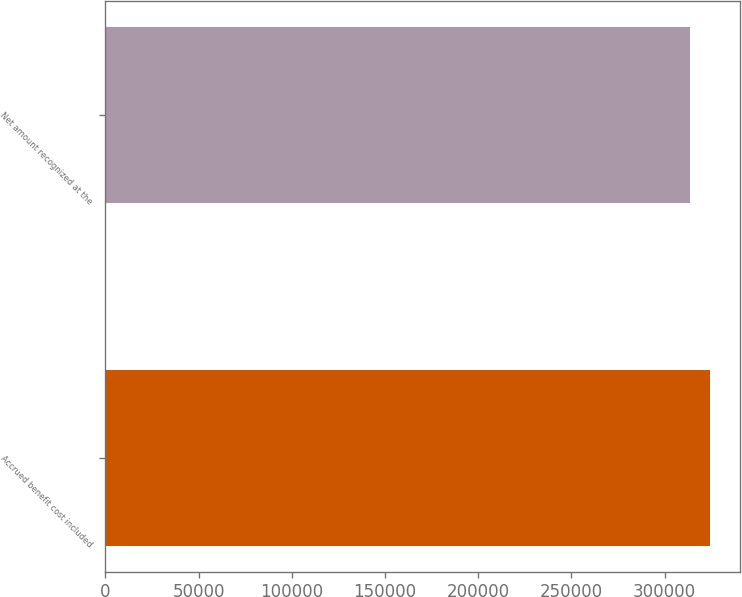Convert chart. <chart><loc_0><loc_0><loc_500><loc_500><bar_chart><fcel>Accrued benefit cost included<fcel>Net amount recognized at the<nl><fcel>324298<fcel>313395<nl></chart> 